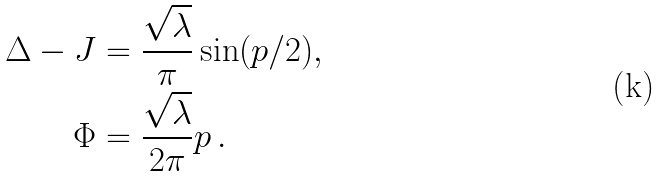Convert formula to latex. <formula><loc_0><loc_0><loc_500><loc_500>\Delta - J & = \frac { \sqrt { \lambda } } { \pi } \sin ( p / 2 ) , \\ \Phi & = \frac { \sqrt { \lambda } } { 2 \pi } p \, .</formula> 